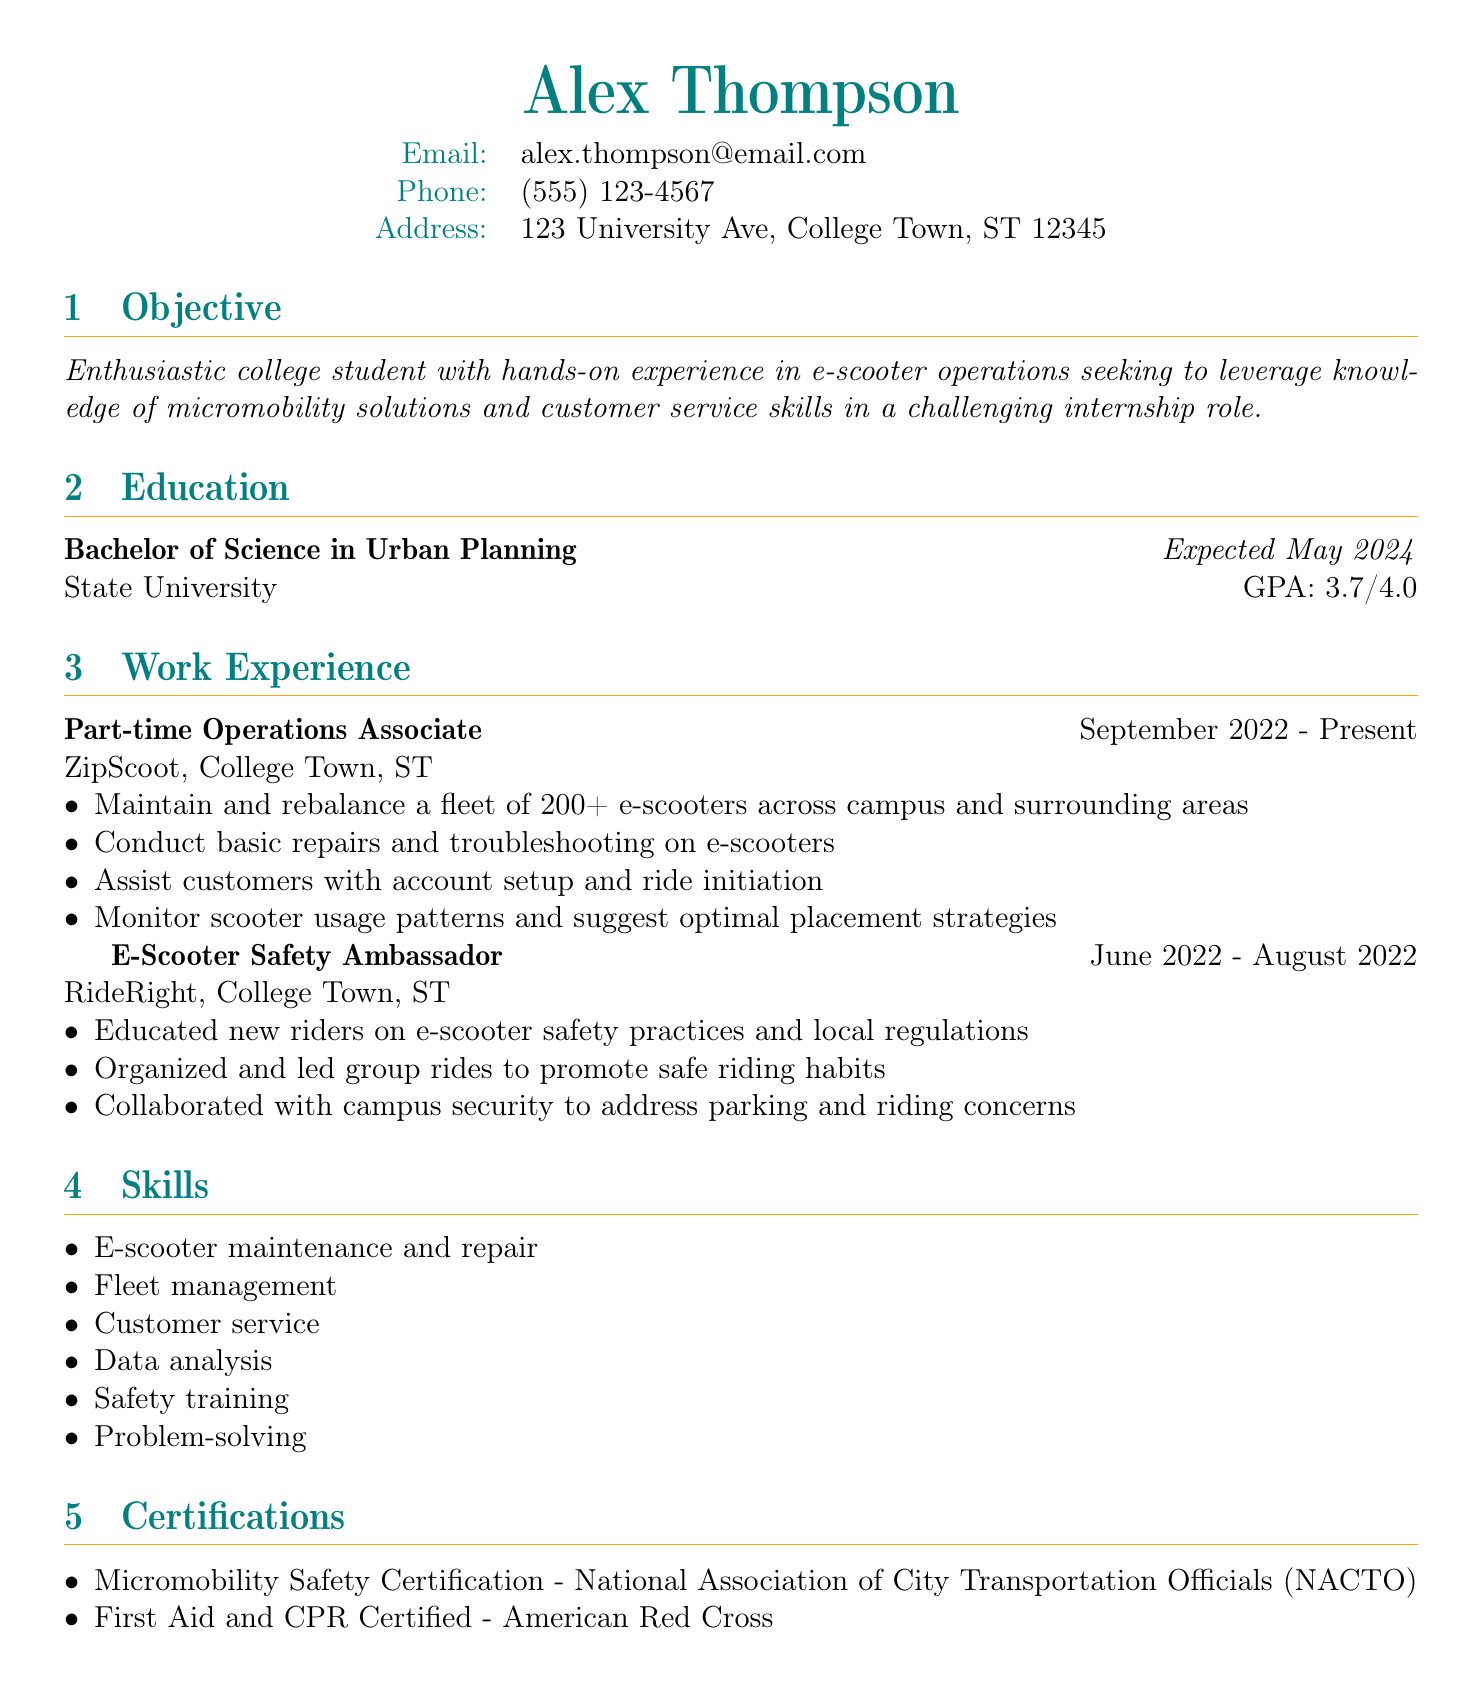What is the name of the applicant? The name of the applicant is listed at the top of the document.
Answer: Alex Thompson What is the expected graduation date? The expected graduation date is mentioned in the education section of the document.
Answer: Expected May 2024 Which company did Alex work for as a part-time Operations Associate? The work experience section provides details about the companies where Alex has worked.
Answer: ZipScoot What certification is mentioned related to micromobility? The certifications section lists relevant certifications held by the applicant.
Answer: Micromobility Safety Certification - National Association of City Transportation Officials (NACTO) How many e-scooters does Alex manage in their current job? The responsibilities in the work experience section specify the number of e-scooters managed.
Answer: 200+ What was one of Alex's responsibilities as an E-Scooter Safety Ambassador? This question examines specific duties from the E-Scooter Safety Ambassador role in the work experience section.
Answer: Educated new riders on e-scooter safety practices and local regulations What is Alex's GPA? The education section includes academic performance metrics such as GPA.
Answer: 3.7/4.0 Which skill relates to managing the e-scooter fleet? The skills section includes various competencies relevant to Alex's job responsibilities.
Answer: Fleet management Why is Alex pursuing an internship? The objective gives insight into the applicant's motivation for seeking an internship.
Answer: To leverage knowledge of micromobility solutions and customer service skills 